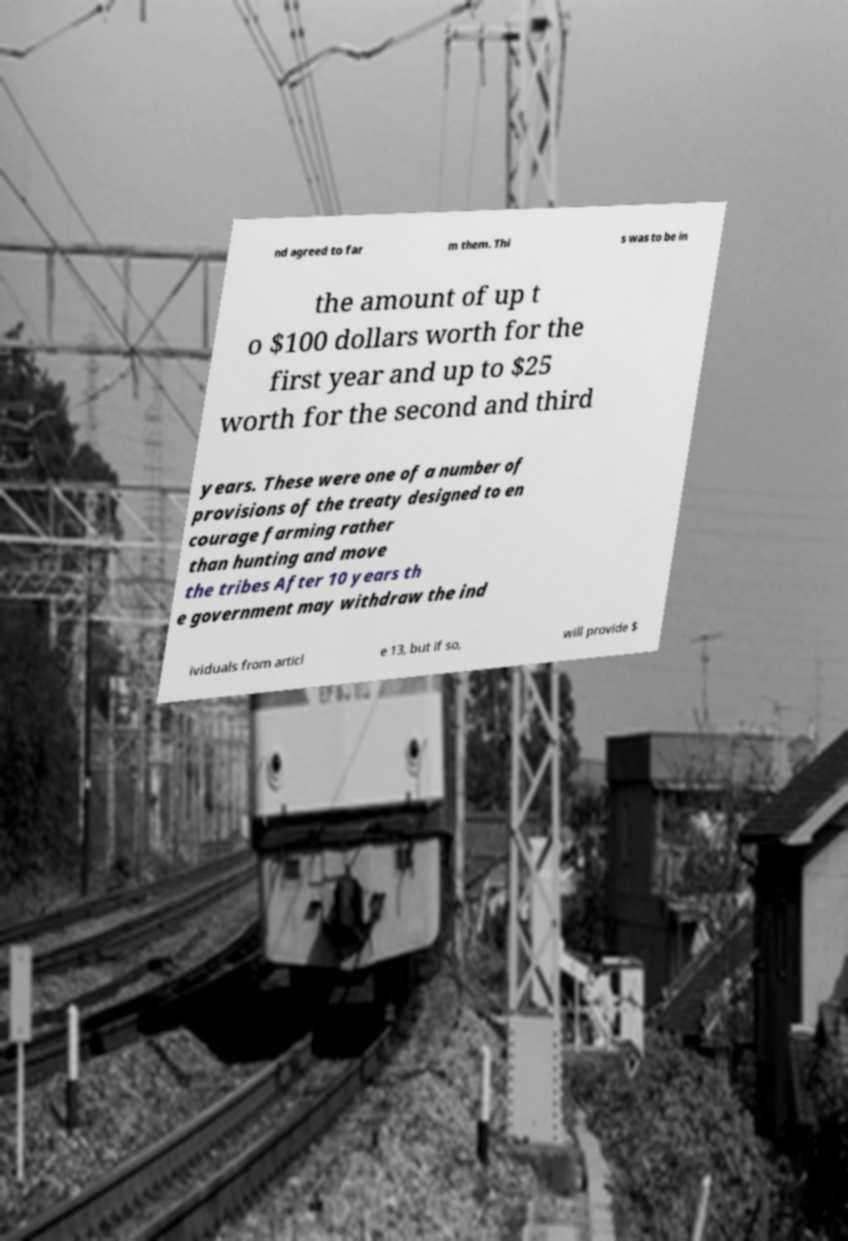Could you assist in decoding the text presented in this image and type it out clearly? nd agreed to far m them. Thi s was to be in the amount of up t o $100 dollars worth for the first year and up to $25 worth for the second and third years. These were one of a number of provisions of the treaty designed to en courage farming rather than hunting and move the tribes After 10 years th e government may withdraw the ind ividuals from articl e 13, but if so, will provide $ 